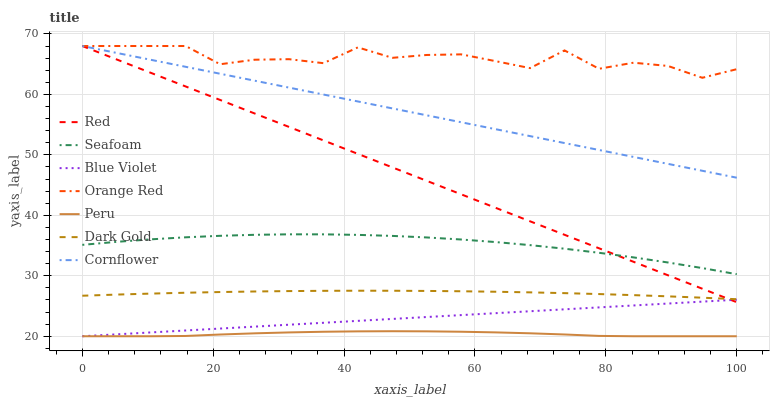Does Peru have the minimum area under the curve?
Answer yes or no. Yes. Does Orange Red have the maximum area under the curve?
Answer yes or no. Yes. Does Dark Gold have the minimum area under the curve?
Answer yes or no. No. Does Dark Gold have the maximum area under the curve?
Answer yes or no. No. Is Blue Violet the smoothest?
Answer yes or no. Yes. Is Orange Red the roughest?
Answer yes or no. Yes. Is Dark Gold the smoothest?
Answer yes or no. No. Is Dark Gold the roughest?
Answer yes or no. No. Does Peru have the lowest value?
Answer yes or no. Yes. Does Dark Gold have the lowest value?
Answer yes or no. No. Does Orange Red have the highest value?
Answer yes or no. Yes. Does Dark Gold have the highest value?
Answer yes or no. No. Is Dark Gold less than Seafoam?
Answer yes or no. Yes. Is Seafoam greater than Dark Gold?
Answer yes or no. Yes. Does Red intersect Blue Violet?
Answer yes or no. Yes. Is Red less than Blue Violet?
Answer yes or no. No. Is Red greater than Blue Violet?
Answer yes or no. No. Does Dark Gold intersect Seafoam?
Answer yes or no. No. 